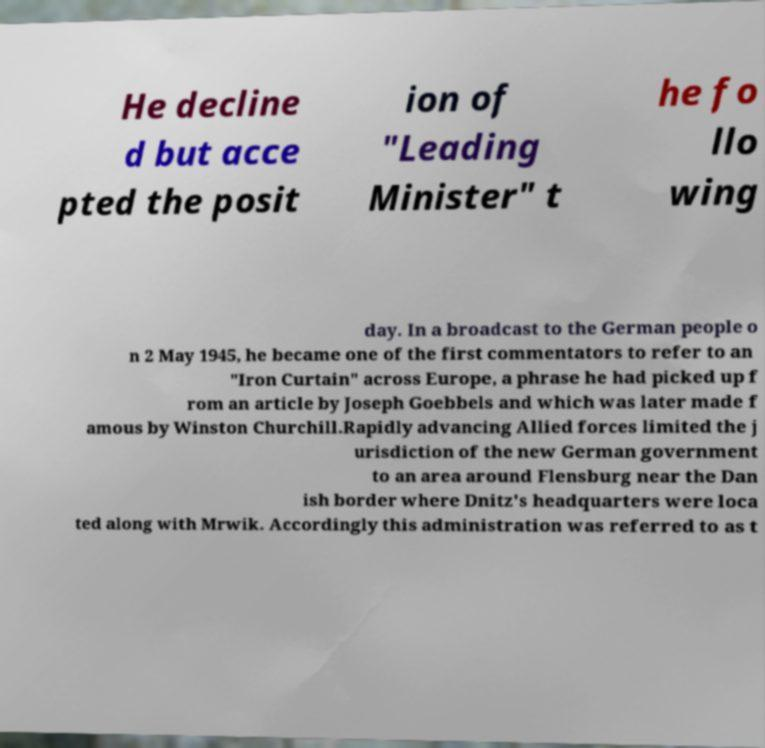Can you read and provide the text displayed in the image?This photo seems to have some interesting text. Can you extract and type it out for me? He decline d but acce pted the posit ion of "Leading Minister" t he fo llo wing day. In a broadcast to the German people o n 2 May 1945, he became one of the first commentators to refer to an "Iron Curtain" across Europe, a phrase he had picked up f rom an article by Joseph Goebbels and which was later made f amous by Winston Churchill.Rapidly advancing Allied forces limited the j urisdiction of the new German government to an area around Flensburg near the Dan ish border where Dnitz's headquarters were loca ted along with Mrwik. Accordingly this administration was referred to as t 